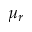<formula> <loc_0><loc_0><loc_500><loc_500>\mu _ { r }</formula> 